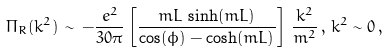Convert formula to latex. <formula><loc_0><loc_0><loc_500><loc_500>\Pi _ { R } ( k ^ { 2 } ) \, \sim \, - \frac { e ^ { 2 } } { 3 0 \pi } \left [ \frac { m L \, \sinh ( m L ) } { \cos ( \phi ) - \cosh ( m L ) } \right ] \, \frac { k ^ { 2 } } { m ^ { 2 } } \, , \, k ^ { 2 } \sim 0 \, ,</formula> 